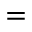Convert formula to latex. <formula><loc_0><loc_0><loc_500><loc_500>=</formula> 